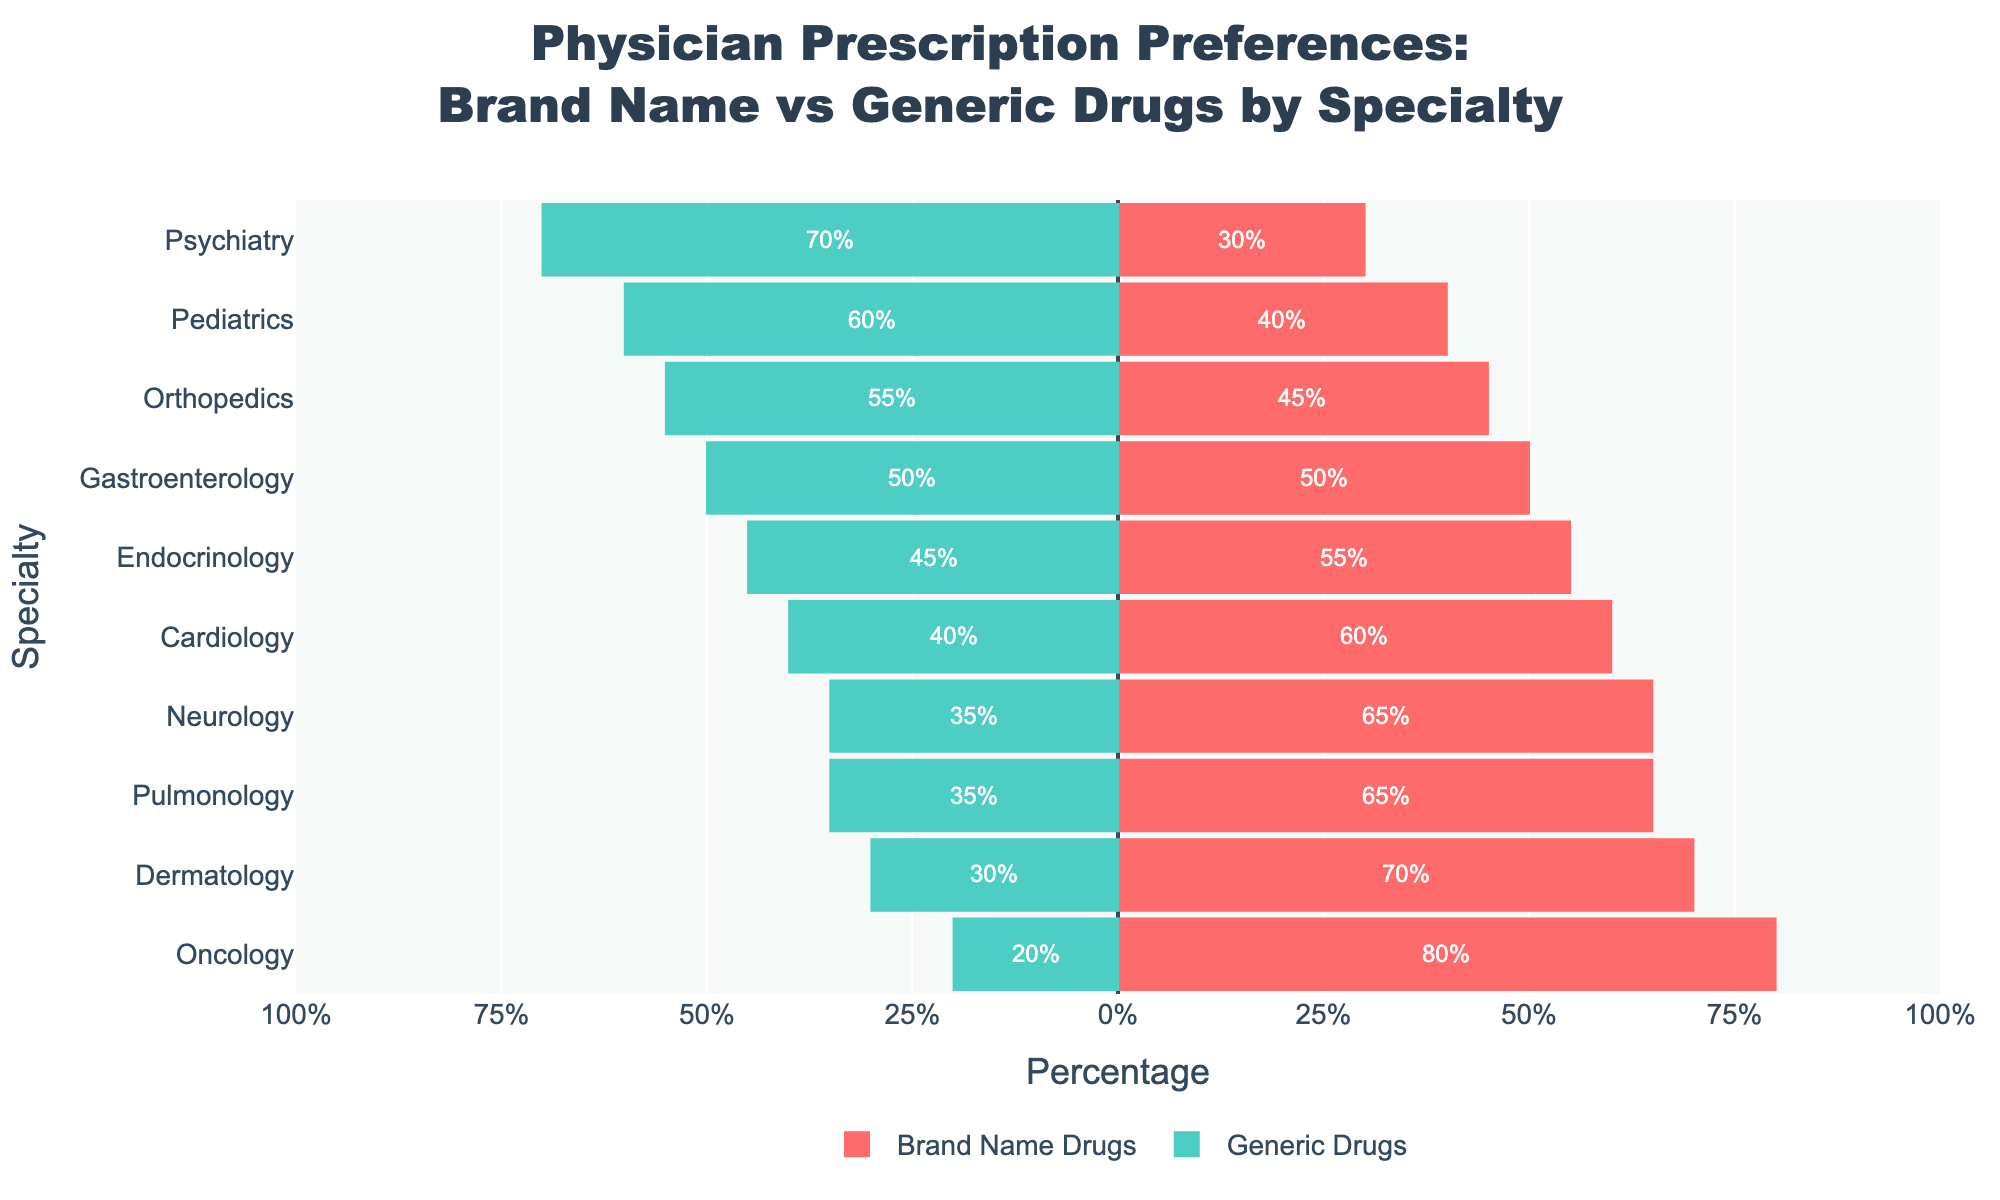what specialty shows the highest preference for brand name drugs? The length of the bars representing brand name drugs indicates the preference. Oncology has the longest bar in the positive direction, indicating the highest preference for brand name drugs.
Answer: Oncology which specialties have an equal preference for brand name and generic drugs? Look for bars where brand name and generic drugs are of equal length. Gastroenterology has equal length bars in both directions, indicating equal preference.
Answer: Gastroenterology what is the difference in preference for brand name drugs between Oncology and Cardiology? Subtract Cardiology's preference for brand name drugs from Oncology's preference. Oncology is at 80% and Cardiology is at 60%, so the difference is 80% - 60% = 20%.
Answer: 20% which specialty shows the greatest preference for generic drugs? The length of the bars representing generic drugs indicates the preference. Psychiatry has the longest bar in the negative direction, indicating the greatest preference for generic drugs.
Answer: Psychiatry if you combine the preferences of Endocrinology and Pulmonology for brand name drugs, what is the total percentage? Sum the percentages for Endocrinology and Pulmonology. Endocrinology is at 55% and Pulmonology is at 65%, so the total is 55% + 65% = 120%.
Answer: 120% which specialties prefer brand name drugs over generic drugs by more than 20%? Compute the difference between brand name and generic drugs for each specialty and identify those with a difference greater than 20%. Cardiology (60-40=20%), Dermatology (70-30=40%), Neurology (65-35=30%), Oncology (80-20=60%), and Pulmonology (65-35=30%).
Answer: Dermatology, Neurology, Oncology, Pulmonology how many specialties have a preference difference (brand name - generic) within 10%? Compute the difference between brand name and generic drugs for each specialty and count those with an absolute value of 10 or less. These specialties are Cardiology (20%), Endocrinology (10%), Gastroenterology (0%), and Orthopedics (-10%).
Answer: 3 which specialty has an equal 50% preference for both brand name and generic drugs? Identify the specialty with equal bar lengths at the 50% mark. Gastroenterology has 50% for both brand name and generic drugs.
Answer: Gastroenterology if you average the preferences for brand name drugs for Cardiology, Endocrinology, and Neurology, what is the result? Find the sum of percentages and then calculate the average. (60% + 55% + 65%) / 3 = 180% / 3 = 60%.
Answer: 60% which specialty shows the lowest preference for brand name drugs? The shortest bar in the positive direction represents the specialty with the lowest preference for brand name drugs. Psychiatry has the shortest bar at 30%.
Answer: Psychiatry 